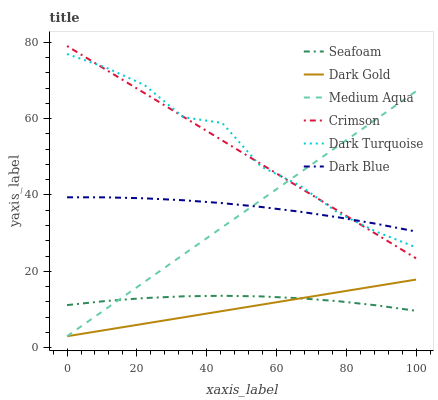Does Dark Gold have the minimum area under the curve?
Answer yes or no. Yes. Does Dark Turquoise have the maximum area under the curve?
Answer yes or no. Yes. Does Seafoam have the minimum area under the curve?
Answer yes or no. No. Does Seafoam have the maximum area under the curve?
Answer yes or no. No. Is Dark Gold the smoothest?
Answer yes or no. Yes. Is Dark Turquoise the roughest?
Answer yes or no. Yes. Is Seafoam the smoothest?
Answer yes or no. No. Is Seafoam the roughest?
Answer yes or no. No. Does Dark Gold have the lowest value?
Answer yes or no. Yes. Does Dark Turquoise have the lowest value?
Answer yes or no. No. Does Crimson have the highest value?
Answer yes or no. Yes. Does Dark Turquoise have the highest value?
Answer yes or no. No. Is Seafoam less than Dark Turquoise?
Answer yes or no. Yes. Is Crimson greater than Dark Gold?
Answer yes or no. Yes. Does Crimson intersect Medium Aqua?
Answer yes or no. Yes. Is Crimson less than Medium Aqua?
Answer yes or no. No. Is Crimson greater than Medium Aqua?
Answer yes or no. No. Does Seafoam intersect Dark Turquoise?
Answer yes or no. No. 